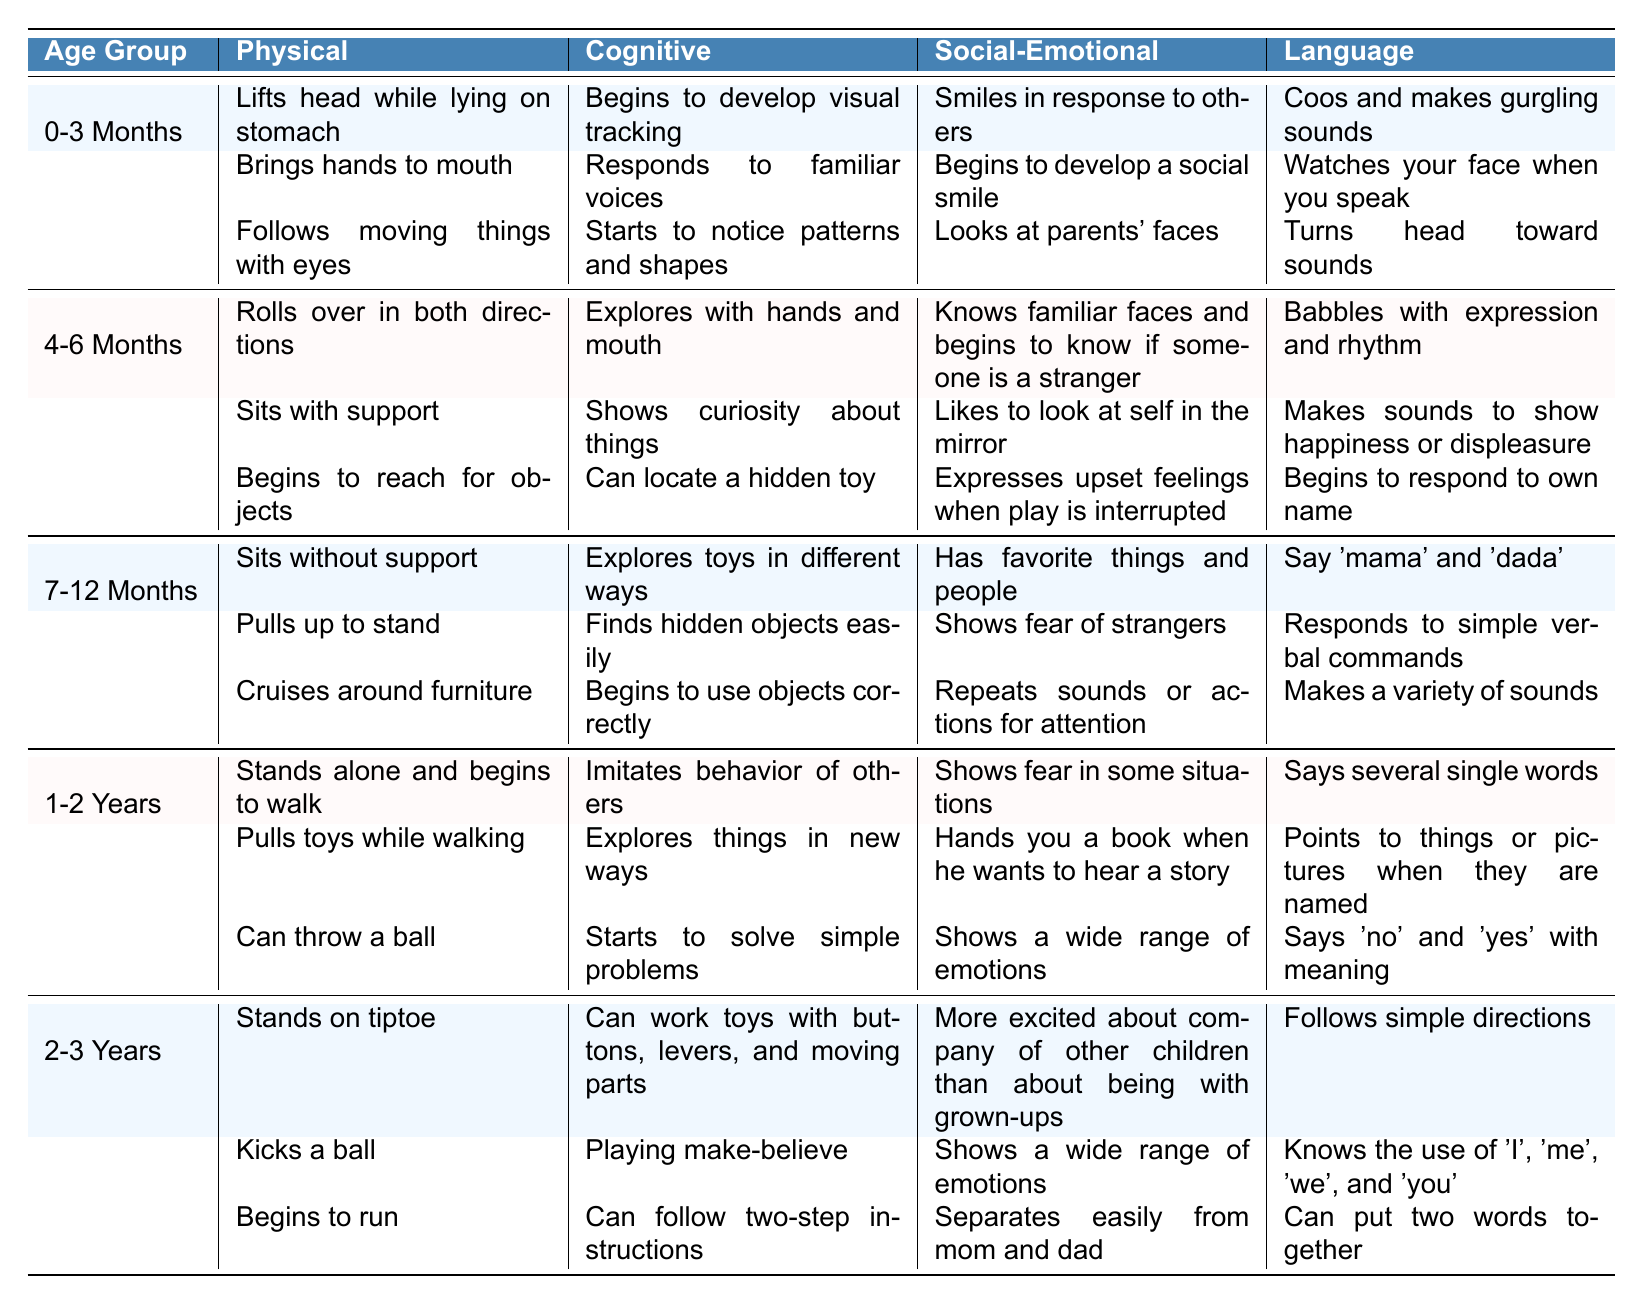What language milestone is first achieved in the 0-3 months age group? The first language milestone listed for the 0-3 months age group is "Coos and makes gurgling sounds." This is found under the Language column for that age group.
Answer: Coos and makes gurgling sounds Which age group shows children can "kick a ball"? The ability to "kick a ball" is listed as a physical milestone for the 2-3 years age group, identified under the Physical column.
Answer: 2-3 years How many social-emotional milestones are there for children aged 1-2 years? In the table, there are three social-emotional milestones listed for the 1-2 years age group. This is counted directly from the Social-Emotional column related to that age group.
Answer: Three Is it true that children aged 4-6 months can express upset feelings when play is interrupted? Yes, this fact is true. The milestone "Expresses upset feelings when play is interrupted" is found in the Social-Emotional section for the 4-6 months age group.
Answer: Yes What is the difference in the number of physical milestones between the 0-3 Months and 1-2 Years age groups? The 0-3 Months age group has three physical milestones, while the 1-2 Years age group has three as well. Thus, the difference is 3 - 3 = 0.
Answer: 0 What are the cognitive milestones listed for the 7-12 months age group? The cognitive milestones for the 7-12 months age group are "Explores toys in different ways," "Finds hidden objects easily," and "Begins to use objects correctly." These are all detailed under the Cognitive column for that age group.
Answer: Explores toys in different ways, Finds hidden objects easily, Begins to use objects correctly How many milestones are there in total for the 2-3 years age group? The 2-3 years age group contains 12 milestones: 3 physical, 3 cognitive, 3 social-emotional, and 3 language milestones. The total is calculated as 3 + 3 + 3 + 3 = 12.
Answer: 12 Which age group has the milestone of "sits without support"? The milestone "Sits without support" is listed under the Physical section for the 7-12 months age group. This can be found in the Physical column for that specific age group.
Answer: 7-12 months In what ways do the social-emotional milestones differ between 4-6 months and 1-2 years? At 4-6 months, children know familiar faces and begin to distinguish between strangers, while at 1-2 years, they show a wider range of emotions and start to hand books for stories. The key difference is in emotional awareness and social interaction deepening over time.
Answer: The emotional awareness and interaction deepen over time What percentage of milestones for the 1-2 years age group is related to language development? The 1-2 years age group has 4 milestones overall (3 physical, 3 cognitive, 3 social-emotional, and 4 language), so the percentage for language is (4/10)*100 = 40%.
Answer: 40% 